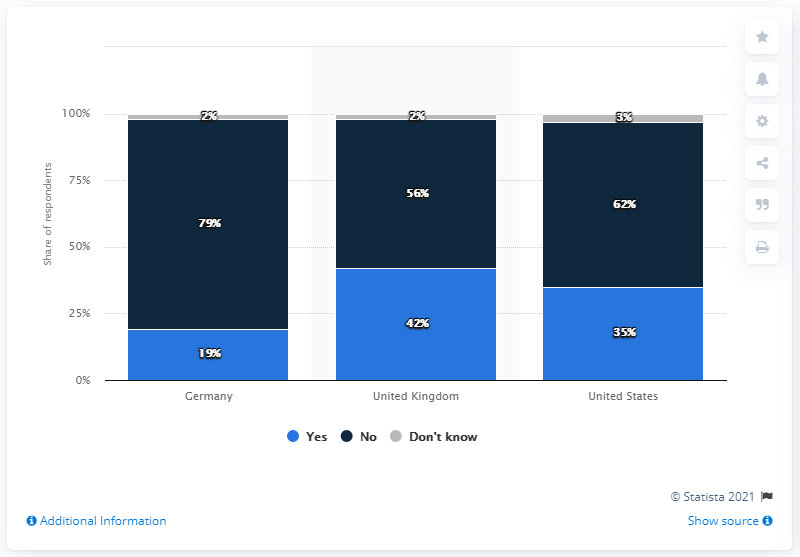Highlight a few significant elements in this photo. The difference between the numbers "6" in the United States and the United Kingdom is one. The percentage of the number who said yes in the United Kingdom is 42%. 